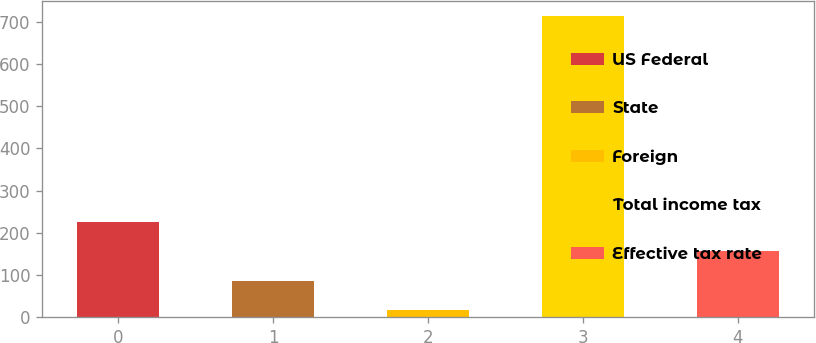Convert chart to OTSL. <chart><loc_0><loc_0><loc_500><loc_500><bar_chart><fcel>US Federal<fcel>State<fcel>Foreign<fcel>Total income tax<fcel>Effective tax rate<nl><fcel>225.8<fcel>86.6<fcel>17<fcel>713<fcel>156.2<nl></chart> 